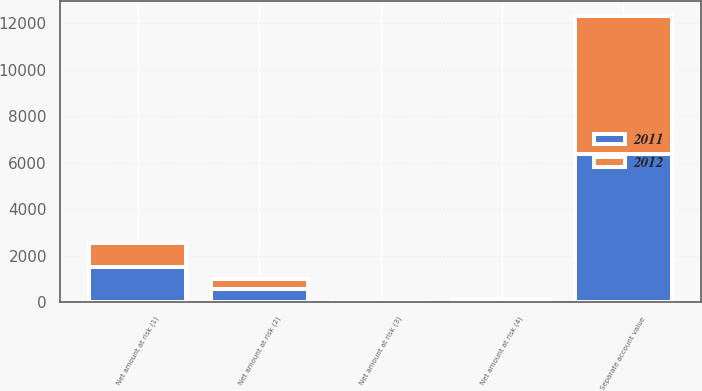Convert chart. <chart><loc_0><loc_0><loc_500><loc_500><stacked_bar_chart><ecel><fcel>Separate account value<fcel>Net amount at risk (1)<fcel>Net amount at risk (2)<fcel>Net amount at risk (3)<fcel>Net amount at risk (4)<nl><fcel>2012<fcel>5947<fcel>1044<fcel>418<fcel>16<fcel>50<nl><fcel>2011<fcel>6372<fcel>1502<fcel>574<fcel>27<fcel>78<nl></chart> 